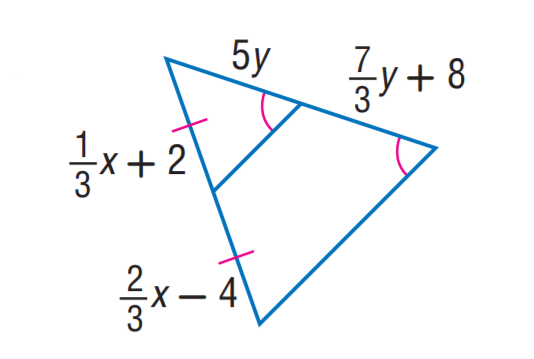Question: Find x.
Choices:
A. 12
B. 15
C. 18
D. 21
Answer with the letter. Answer: C 